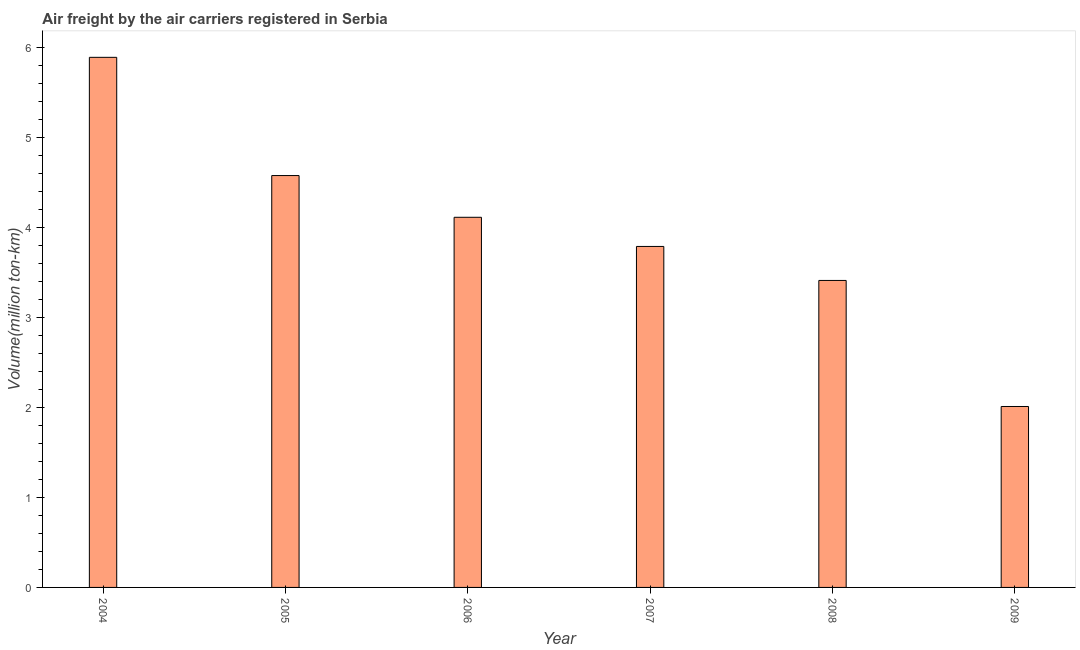What is the title of the graph?
Keep it short and to the point. Air freight by the air carriers registered in Serbia. What is the label or title of the Y-axis?
Your answer should be very brief. Volume(million ton-km). What is the air freight in 2005?
Provide a succinct answer. 4.58. Across all years, what is the maximum air freight?
Offer a terse response. 5.89. Across all years, what is the minimum air freight?
Ensure brevity in your answer.  2.01. In which year was the air freight minimum?
Offer a terse response. 2009. What is the sum of the air freight?
Your response must be concise. 23.8. What is the difference between the air freight in 2008 and 2009?
Your answer should be compact. 1.4. What is the average air freight per year?
Provide a short and direct response. 3.97. What is the median air freight?
Provide a short and direct response. 3.95. What is the ratio of the air freight in 2004 to that in 2006?
Make the answer very short. 1.43. Is the difference between the air freight in 2005 and 2009 greater than the difference between any two years?
Offer a terse response. No. What is the difference between the highest and the second highest air freight?
Provide a succinct answer. 1.31. Is the sum of the air freight in 2007 and 2008 greater than the maximum air freight across all years?
Provide a succinct answer. Yes. What is the difference between the highest and the lowest air freight?
Offer a very short reply. 3.88. How many bars are there?
Provide a succinct answer. 6. Are all the bars in the graph horizontal?
Keep it short and to the point. No. Are the values on the major ticks of Y-axis written in scientific E-notation?
Provide a succinct answer. No. What is the Volume(million ton-km) in 2004?
Your answer should be compact. 5.89. What is the Volume(million ton-km) of 2005?
Ensure brevity in your answer.  4.58. What is the Volume(million ton-km) in 2006?
Keep it short and to the point. 4.11. What is the Volume(million ton-km) in 2007?
Your answer should be very brief. 3.79. What is the Volume(million ton-km) in 2008?
Make the answer very short. 3.41. What is the Volume(million ton-km) of 2009?
Your response must be concise. 2.01. What is the difference between the Volume(million ton-km) in 2004 and 2005?
Your answer should be very brief. 1.31. What is the difference between the Volume(million ton-km) in 2004 and 2006?
Offer a very short reply. 1.78. What is the difference between the Volume(million ton-km) in 2004 and 2007?
Offer a very short reply. 2.1. What is the difference between the Volume(million ton-km) in 2004 and 2008?
Give a very brief answer. 2.48. What is the difference between the Volume(million ton-km) in 2004 and 2009?
Your response must be concise. 3.88. What is the difference between the Volume(million ton-km) in 2005 and 2006?
Your answer should be compact. 0.46. What is the difference between the Volume(million ton-km) in 2005 and 2007?
Make the answer very short. 0.79. What is the difference between the Volume(million ton-km) in 2005 and 2008?
Keep it short and to the point. 1.17. What is the difference between the Volume(million ton-km) in 2005 and 2009?
Make the answer very short. 2.57. What is the difference between the Volume(million ton-km) in 2006 and 2007?
Offer a very short reply. 0.32. What is the difference between the Volume(million ton-km) in 2006 and 2008?
Provide a short and direct response. 0.7. What is the difference between the Volume(million ton-km) in 2006 and 2009?
Your answer should be compact. 2.1. What is the difference between the Volume(million ton-km) in 2007 and 2008?
Give a very brief answer. 0.38. What is the difference between the Volume(million ton-km) in 2007 and 2009?
Ensure brevity in your answer.  1.78. What is the difference between the Volume(million ton-km) in 2008 and 2009?
Your response must be concise. 1.4. What is the ratio of the Volume(million ton-km) in 2004 to that in 2005?
Ensure brevity in your answer.  1.29. What is the ratio of the Volume(million ton-km) in 2004 to that in 2006?
Keep it short and to the point. 1.43. What is the ratio of the Volume(million ton-km) in 2004 to that in 2007?
Your response must be concise. 1.55. What is the ratio of the Volume(million ton-km) in 2004 to that in 2008?
Offer a terse response. 1.73. What is the ratio of the Volume(million ton-km) in 2004 to that in 2009?
Keep it short and to the point. 2.93. What is the ratio of the Volume(million ton-km) in 2005 to that in 2006?
Provide a succinct answer. 1.11. What is the ratio of the Volume(million ton-km) in 2005 to that in 2007?
Your response must be concise. 1.21. What is the ratio of the Volume(million ton-km) in 2005 to that in 2008?
Provide a short and direct response. 1.34. What is the ratio of the Volume(million ton-km) in 2005 to that in 2009?
Keep it short and to the point. 2.28. What is the ratio of the Volume(million ton-km) in 2006 to that in 2007?
Provide a succinct answer. 1.08. What is the ratio of the Volume(million ton-km) in 2006 to that in 2008?
Make the answer very short. 1.21. What is the ratio of the Volume(million ton-km) in 2006 to that in 2009?
Your response must be concise. 2.05. What is the ratio of the Volume(million ton-km) in 2007 to that in 2008?
Make the answer very short. 1.11. What is the ratio of the Volume(million ton-km) in 2007 to that in 2009?
Ensure brevity in your answer.  1.89. What is the ratio of the Volume(million ton-km) in 2008 to that in 2009?
Provide a succinct answer. 1.7. 